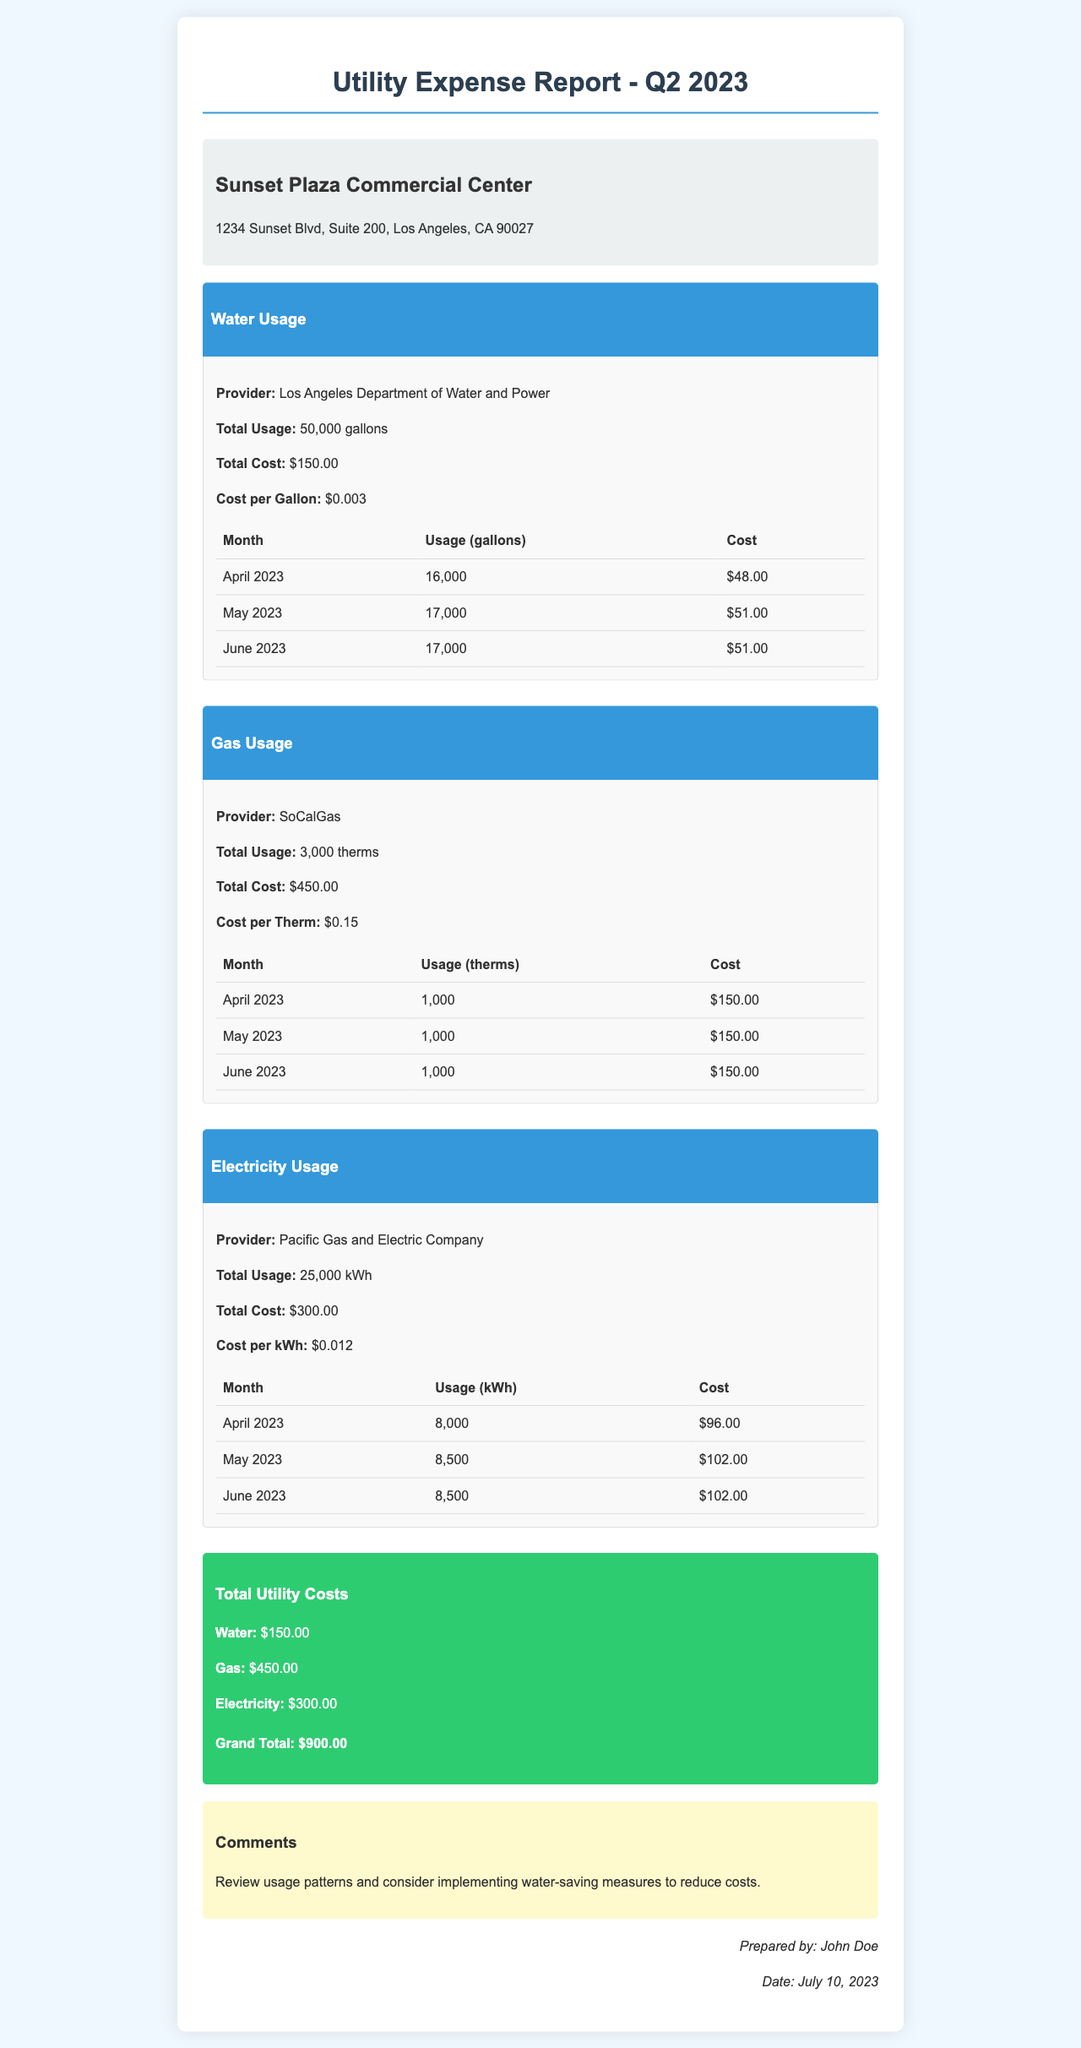What is the total usage for water in Q2 2023? The total usage for water is stated in the document as 50,000 gallons.
Answer: 50,000 gallons What is the total cost for gas? The total cost for gas is explicitly mentioned in the document as $450.00.
Answer: $450.00 What is the provider for electricity? The provider for electricity is given in the document as Pacific Gas and Electric Company.
Answer: Pacific Gas and Electric Company How much was spent on electricity in May 2023? The document provides the cost for electricity in May 2023 as $102.00.
Answer: $102.00 What is the total utility cost for Q2 2023? The total utility costs are summarized in the document as $900.00.
Answer: $900.00 What measures are suggested in the comments section? The comments suggest reviewing usage patterns and implementing water-saving measures.
Answer: water-saving measures How many therms were used in June 2023? The document states the usage of gas in June 2023 as 1,000 therms.
Answer: 1,000 therms What is the cost per gallon for water? The document lists the cost per gallon for water as $0.003.
Answer: $0.003 What was the usage of electricity in April 2023? According to the document, the usage of electricity in April 2023 was 8,000 kWh.
Answer: 8,000 kWh 